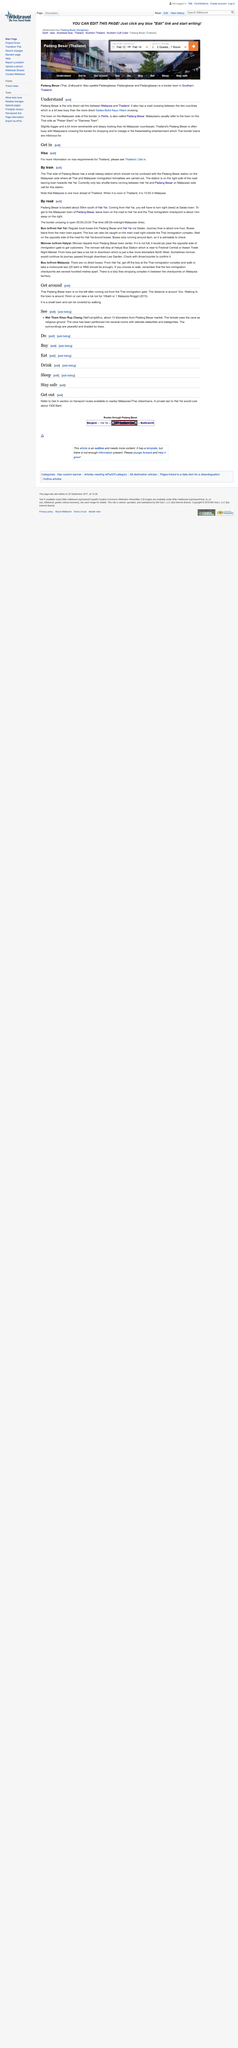Give some essential details in this illustration. Padang Besar is located approximately 50 kilometers south of Hat Yai. The Padang Besar Station in Thailand is headed towards Hat Yai. There exists two Padang Besar, one in Malaysia and the other in Thailand. The Padang Besar in Thailand is more sleazy-looking than the one in Malaysia. Wat Tham Khao Rup Chang is approximately 13 kilometers from Padang Besar market. The bus journey time between Padang Besar and Hat Yai is approximately one hour. 